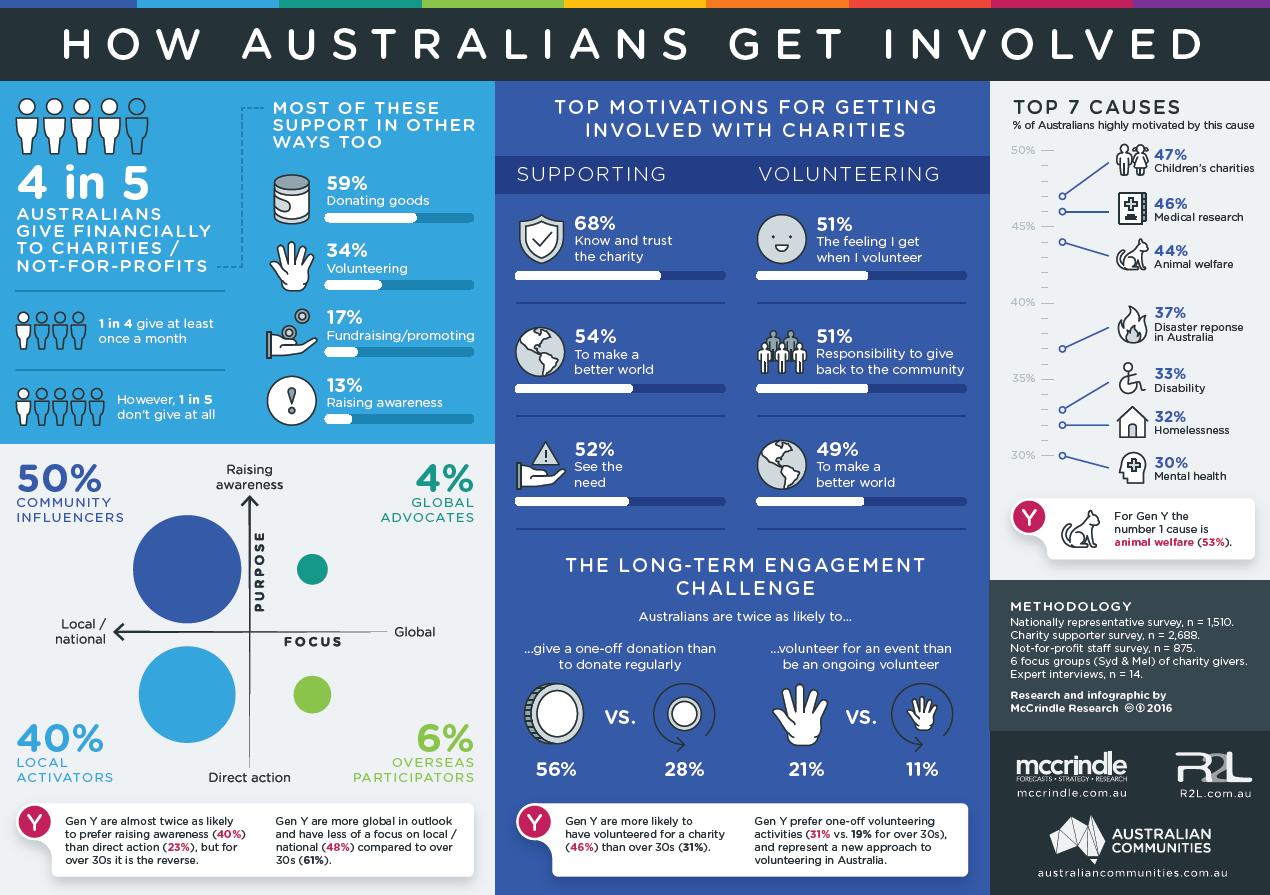Point out several critical features in this image. According to a recent survey, 13% of Australians are actively involved in raising awareness about providing financial assistance to charities. According to a recent survey, 59% of Australians donate goods to charities. It is estimated that approximately 28% of Australians regularly donate to charity. It is observed that the gender of Gen Y is highly motivated by the cause of animal welfare in Australia. According to the study, 50% of community influencers are involved in raising awareness among Australians about the importance of preventing type 2 diabetes. 